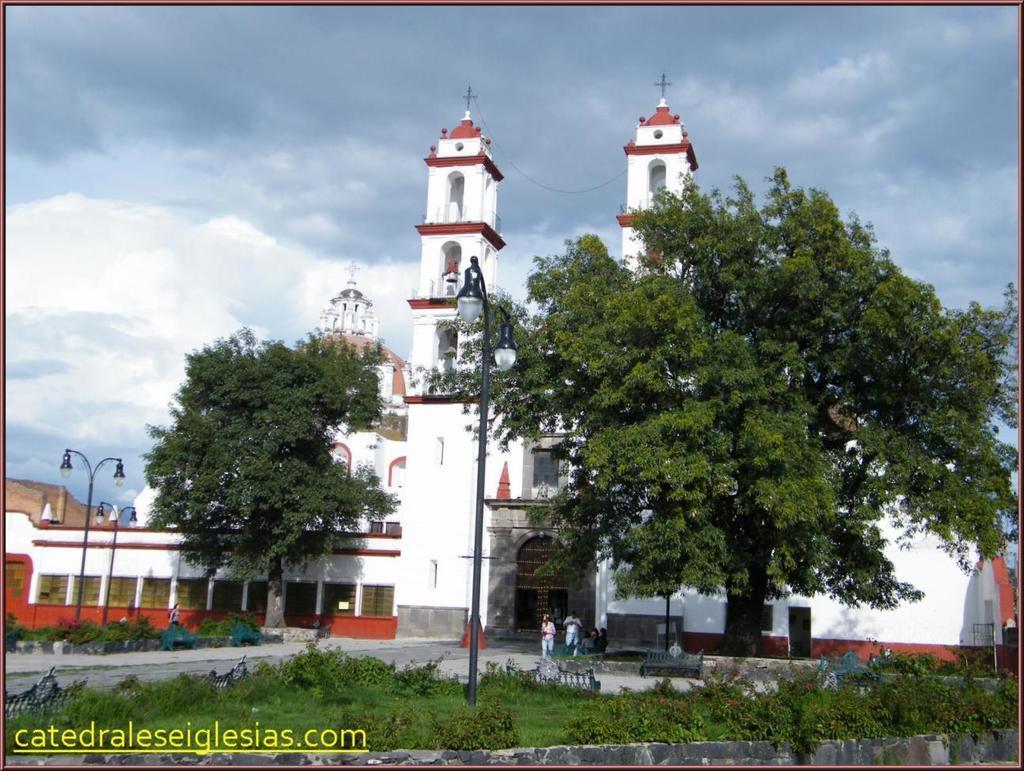How would you summarize this image in a sentence or two? In this picture I can observe building in the middle of the picture. In front of the building there are trees and some plants on the ground. In the background I can observe some clouds in the sky. 